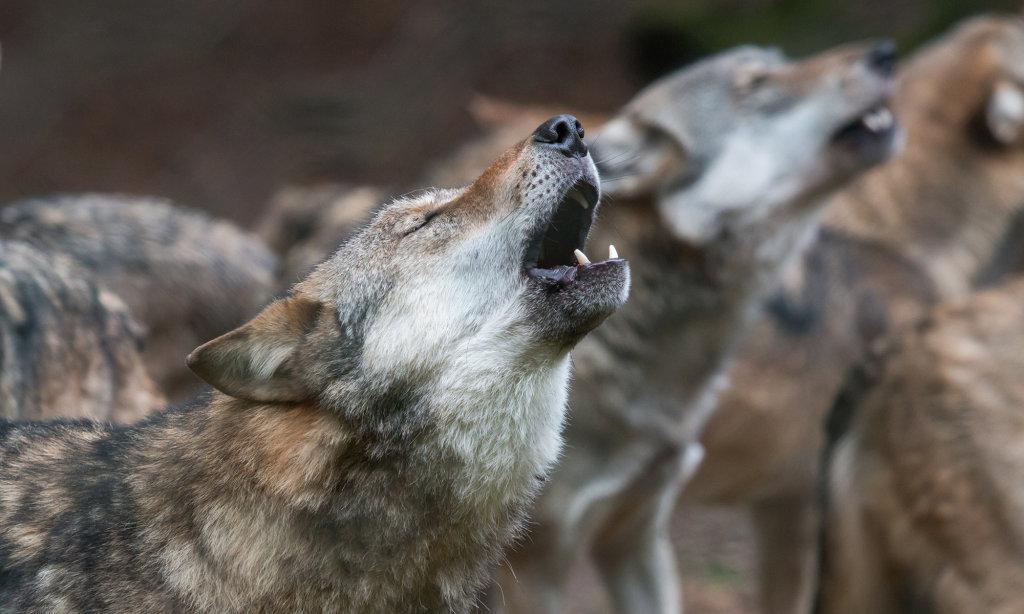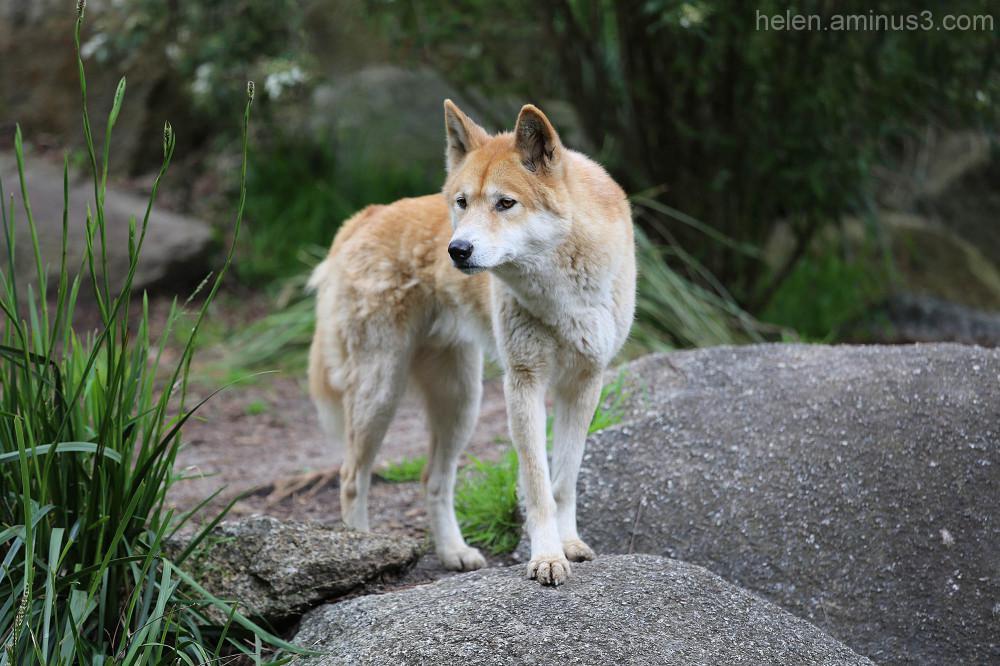The first image is the image on the left, the second image is the image on the right. Assess this claim about the two images: "An image contains at least two canines.". Correct or not? Answer yes or no. Yes. The first image is the image on the left, the second image is the image on the right. For the images displayed, is the sentence "Some of the dingoes are howling." factually correct? Answer yes or no. Yes. 